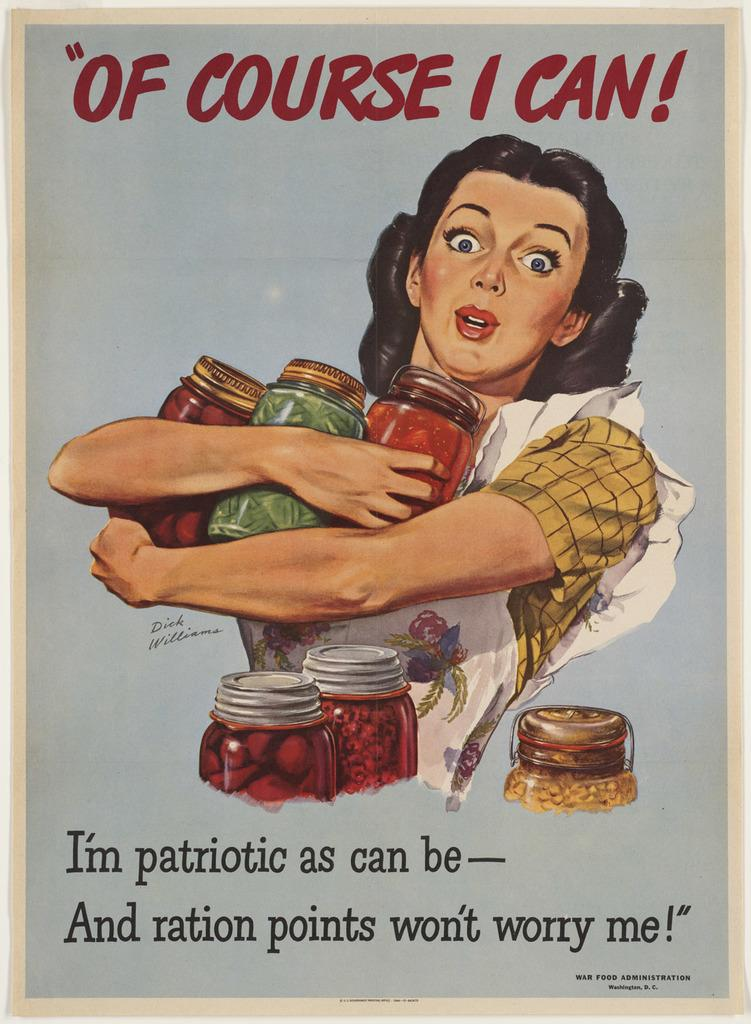<image>
Offer a succinct explanation of the picture presented. A poster that says of course I can at the top shows a woman holding jars of food. 